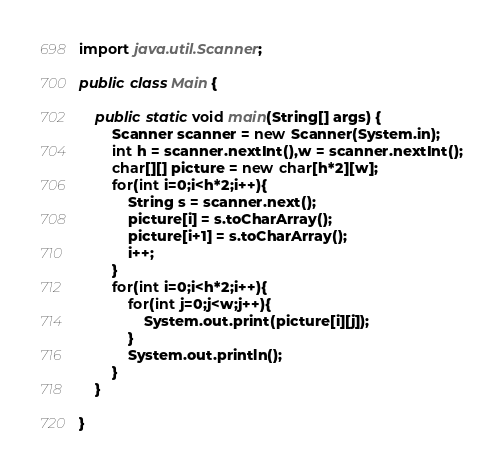<code> <loc_0><loc_0><loc_500><loc_500><_Java_>import java.util.Scanner;

public class Main {

	public static void main(String[] args) {
		Scanner scanner = new Scanner(System.in);
		int h = scanner.nextInt(),w = scanner.nextInt();
		char[][] picture = new char[h*2][w];
		for(int i=0;i<h*2;i++){
			String s = scanner.next();
			picture[i] = s.toCharArray();
			picture[i+1] = s.toCharArray();
			i++;
		}
		for(int i=0;i<h*2;i++){
			for(int j=0;j<w;j++){
				System.out.print(picture[i][j]);
			}
			System.out.println();
		}
	}

}
</code> 